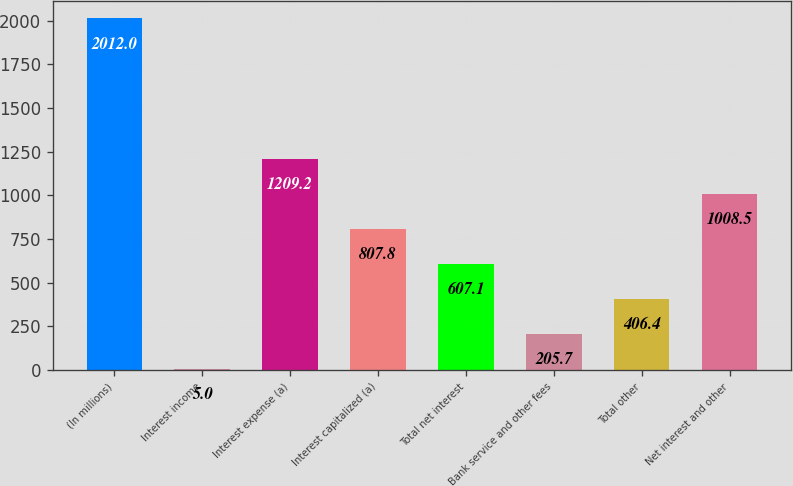Convert chart to OTSL. <chart><loc_0><loc_0><loc_500><loc_500><bar_chart><fcel>(In millions)<fcel>Interest income<fcel>Interest expense (a)<fcel>Interest capitalized (a)<fcel>Total net interest<fcel>Bank service and other fees<fcel>Total other<fcel>Net interest and other<nl><fcel>2012<fcel>5<fcel>1209.2<fcel>807.8<fcel>607.1<fcel>205.7<fcel>406.4<fcel>1008.5<nl></chart> 